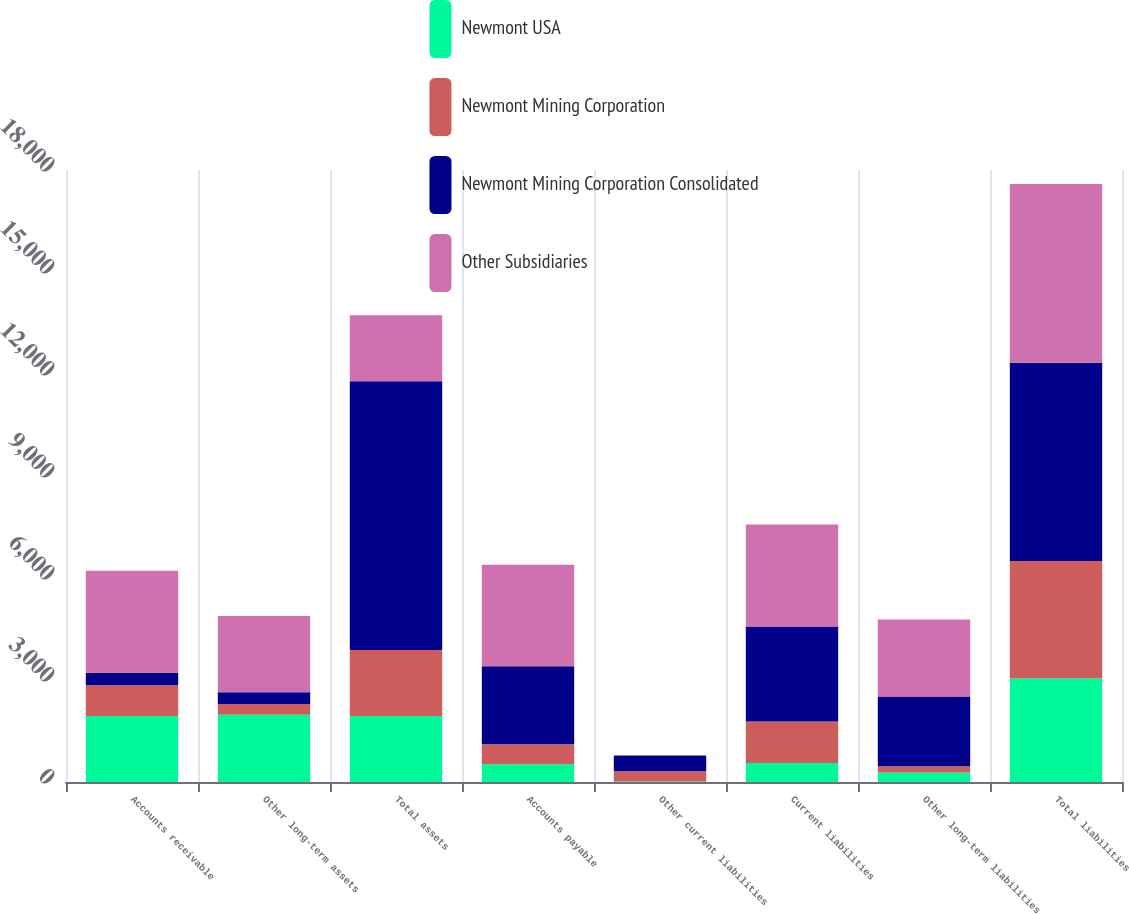<chart> <loc_0><loc_0><loc_500><loc_500><stacked_bar_chart><ecel><fcel>Accounts receivable<fcel>Other long-term assets<fcel>Total assets<fcel>Accounts payable<fcel>Other current liabilities<fcel>Current liabilities<fcel>Other long-term liabilities<fcel>Total liabilities<nl><fcel>Newmont USA<fcel>1941<fcel>1977<fcel>1941<fcel>524<fcel>15<fcel>560<fcel>283<fcel>3050<nl><fcel>Newmont Mining Corporation<fcel>904<fcel>320<fcel>1941<fcel>586<fcel>303<fcel>1223<fcel>182<fcel>3450<nl><fcel>Newmont Mining Corporation Consolidated<fcel>370<fcel>341<fcel>7906<fcel>2292<fcel>461<fcel>2794<fcel>2049<fcel>5828<nl><fcel>Other Subsidiaries<fcel>3001<fcel>2243<fcel>1941<fcel>2991<fcel>9<fcel>3000<fcel>2262<fcel>5262<nl></chart> 